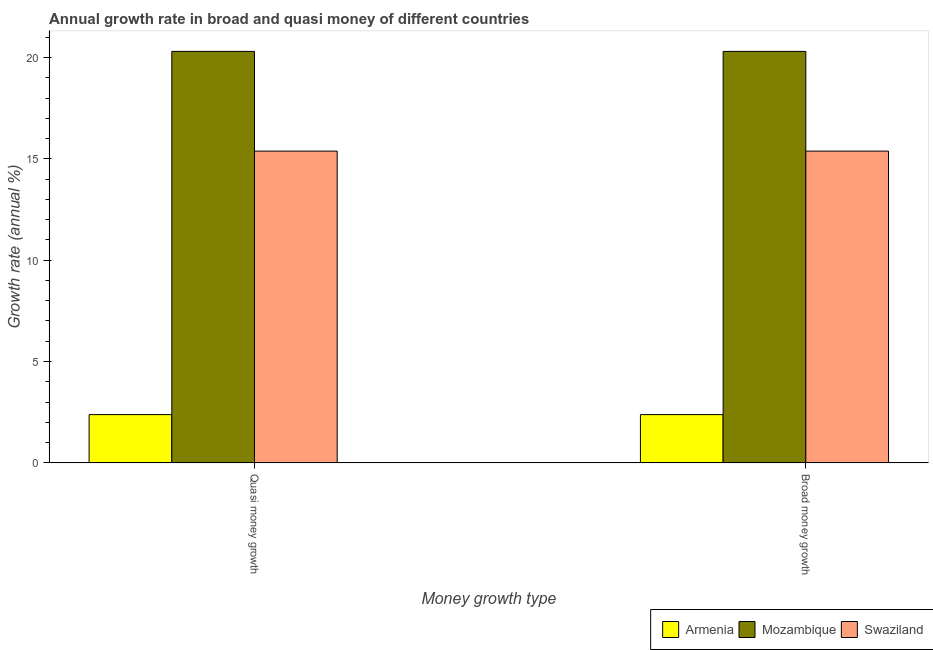Are the number of bars per tick equal to the number of legend labels?
Ensure brevity in your answer.  Yes. How many bars are there on the 1st tick from the right?
Give a very brief answer. 3. What is the label of the 1st group of bars from the left?
Your response must be concise. Quasi money growth. What is the annual growth rate in quasi money in Armenia?
Your answer should be compact. 2.38. Across all countries, what is the maximum annual growth rate in quasi money?
Your answer should be compact. 20.3. Across all countries, what is the minimum annual growth rate in broad money?
Offer a very short reply. 2.38. In which country was the annual growth rate in quasi money maximum?
Make the answer very short. Mozambique. In which country was the annual growth rate in quasi money minimum?
Your response must be concise. Armenia. What is the total annual growth rate in quasi money in the graph?
Make the answer very short. 38.07. What is the difference between the annual growth rate in quasi money in Mozambique and that in Armenia?
Offer a very short reply. 17.93. What is the difference between the annual growth rate in broad money in Mozambique and the annual growth rate in quasi money in Armenia?
Give a very brief answer. 17.93. What is the average annual growth rate in quasi money per country?
Your answer should be very brief. 12.69. What is the ratio of the annual growth rate in broad money in Swaziland to that in Mozambique?
Offer a terse response. 0.76. Is the annual growth rate in quasi money in Swaziland less than that in Armenia?
Keep it short and to the point. No. In how many countries, is the annual growth rate in quasi money greater than the average annual growth rate in quasi money taken over all countries?
Your answer should be very brief. 2. What does the 2nd bar from the left in Quasi money growth represents?
Ensure brevity in your answer.  Mozambique. What does the 3rd bar from the right in Quasi money growth represents?
Ensure brevity in your answer.  Armenia. Are all the bars in the graph horizontal?
Offer a very short reply. No. What is the difference between two consecutive major ticks on the Y-axis?
Provide a short and direct response. 5. Are the values on the major ticks of Y-axis written in scientific E-notation?
Your answer should be compact. No. Does the graph contain any zero values?
Offer a very short reply. No. Where does the legend appear in the graph?
Your response must be concise. Bottom right. How are the legend labels stacked?
Give a very brief answer. Horizontal. What is the title of the graph?
Offer a terse response. Annual growth rate in broad and quasi money of different countries. What is the label or title of the X-axis?
Your answer should be compact. Money growth type. What is the label or title of the Y-axis?
Ensure brevity in your answer.  Growth rate (annual %). What is the Growth rate (annual %) of Armenia in Quasi money growth?
Provide a succinct answer. 2.38. What is the Growth rate (annual %) in Mozambique in Quasi money growth?
Keep it short and to the point. 20.3. What is the Growth rate (annual %) of Swaziland in Quasi money growth?
Ensure brevity in your answer.  15.38. What is the Growth rate (annual %) in Armenia in Broad money growth?
Offer a terse response. 2.38. What is the Growth rate (annual %) in Mozambique in Broad money growth?
Offer a very short reply. 20.3. What is the Growth rate (annual %) of Swaziland in Broad money growth?
Your response must be concise. 15.38. Across all Money growth type, what is the maximum Growth rate (annual %) of Armenia?
Your answer should be compact. 2.38. Across all Money growth type, what is the maximum Growth rate (annual %) of Mozambique?
Ensure brevity in your answer.  20.3. Across all Money growth type, what is the maximum Growth rate (annual %) in Swaziland?
Keep it short and to the point. 15.38. Across all Money growth type, what is the minimum Growth rate (annual %) in Armenia?
Keep it short and to the point. 2.38. Across all Money growth type, what is the minimum Growth rate (annual %) of Mozambique?
Offer a terse response. 20.3. Across all Money growth type, what is the minimum Growth rate (annual %) of Swaziland?
Ensure brevity in your answer.  15.38. What is the total Growth rate (annual %) of Armenia in the graph?
Your answer should be very brief. 4.76. What is the total Growth rate (annual %) in Mozambique in the graph?
Give a very brief answer. 40.61. What is the total Growth rate (annual %) of Swaziland in the graph?
Make the answer very short. 30.77. What is the difference between the Growth rate (annual %) in Swaziland in Quasi money growth and that in Broad money growth?
Offer a very short reply. 0. What is the difference between the Growth rate (annual %) in Armenia in Quasi money growth and the Growth rate (annual %) in Mozambique in Broad money growth?
Your answer should be very brief. -17.93. What is the difference between the Growth rate (annual %) in Armenia in Quasi money growth and the Growth rate (annual %) in Swaziland in Broad money growth?
Provide a short and direct response. -13. What is the difference between the Growth rate (annual %) of Mozambique in Quasi money growth and the Growth rate (annual %) of Swaziland in Broad money growth?
Your response must be concise. 4.92. What is the average Growth rate (annual %) of Armenia per Money growth type?
Provide a short and direct response. 2.38. What is the average Growth rate (annual %) in Mozambique per Money growth type?
Make the answer very short. 20.3. What is the average Growth rate (annual %) of Swaziland per Money growth type?
Make the answer very short. 15.38. What is the difference between the Growth rate (annual %) of Armenia and Growth rate (annual %) of Mozambique in Quasi money growth?
Your answer should be very brief. -17.93. What is the difference between the Growth rate (annual %) of Armenia and Growth rate (annual %) of Swaziland in Quasi money growth?
Offer a terse response. -13. What is the difference between the Growth rate (annual %) in Mozambique and Growth rate (annual %) in Swaziland in Quasi money growth?
Keep it short and to the point. 4.92. What is the difference between the Growth rate (annual %) of Armenia and Growth rate (annual %) of Mozambique in Broad money growth?
Your answer should be very brief. -17.93. What is the difference between the Growth rate (annual %) in Armenia and Growth rate (annual %) in Swaziland in Broad money growth?
Ensure brevity in your answer.  -13. What is the difference between the Growth rate (annual %) in Mozambique and Growth rate (annual %) in Swaziland in Broad money growth?
Your answer should be very brief. 4.92. What is the ratio of the Growth rate (annual %) in Mozambique in Quasi money growth to that in Broad money growth?
Your response must be concise. 1. What is the difference between the highest and the second highest Growth rate (annual %) in Mozambique?
Provide a succinct answer. 0. What is the difference between the highest and the second highest Growth rate (annual %) of Swaziland?
Ensure brevity in your answer.  0. What is the difference between the highest and the lowest Growth rate (annual %) of Armenia?
Your response must be concise. 0. What is the difference between the highest and the lowest Growth rate (annual %) of Mozambique?
Your response must be concise. 0. What is the difference between the highest and the lowest Growth rate (annual %) of Swaziland?
Your response must be concise. 0. 